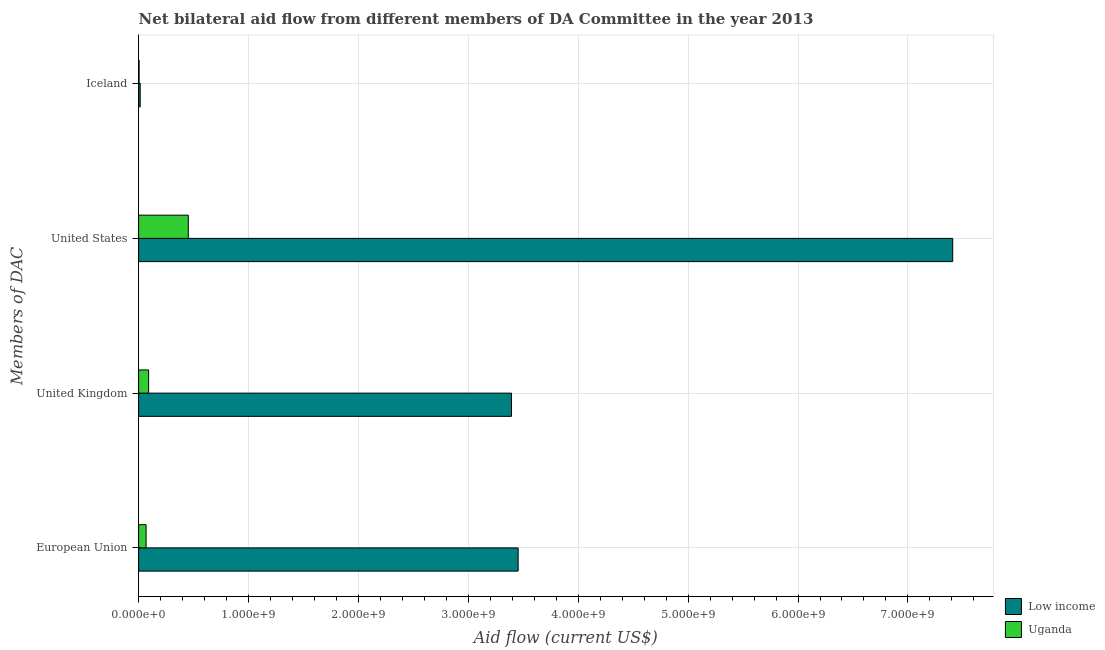How many different coloured bars are there?
Provide a succinct answer. 2. How many bars are there on the 2nd tick from the top?
Ensure brevity in your answer.  2. How many bars are there on the 1st tick from the bottom?
Make the answer very short. 2. What is the label of the 4th group of bars from the top?
Your response must be concise. European Union. What is the amount of aid given by uk in Low income?
Keep it short and to the point. 3.39e+09. Across all countries, what is the maximum amount of aid given by uk?
Ensure brevity in your answer.  3.39e+09. Across all countries, what is the minimum amount of aid given by uk?
Ensure brevity in your answer.  9.09e+07. In which country was the amount of aid given by us minimum?
Offer a terse response. Uganda. What is the total amount of aid given by us in the graph?
Offer a very short reply. 7.86e+09. What is the difference between the amount of aid given by eu in Uganda and that in Low income?
Offer a terse response. -3.39e+09. What is the difference between the amount of aid given by us in Uganda and the amount of aid given by eu in Low income?
Offer a terse response. -3.00e+09. What is the average amount of aid given by uk per country?
Offer a very short reply. 1.74e+09. What is the difference between the amount of aid given by eu and amount of aid given by iceland in Uganda?
Offer a terse response. 6.38e+07. In how many countries, is the amount of aid given by uk greater than 1800000000 US$?
Make the answer very short. 1. What is the ratio of the amount of aid given by uk in Uganda to that in Low income?
Keep it short and to the point. 0.03. Is the difference between the amount of aid given by iceland in Low income and Uganda greater than the difference between the amount of aid given by eu in Low income and Uganda?
Offer a very short reply. No. What is the difference between the highest and the second highest amount of aid given by eu?
Provide a short and direct response. 3.39e+09. What is the difference between the highest and the lowest amount of aid given by iceland?
Give a very brief answer. 1.01e+07. In how many countries, is the amount of aid given by iceland greater than the average amount of aid given by iceland taken over all countries?
Make the answer very short. 1. Is it the case that in every country, the sum of the amount of aid given by uk and amount of aid given by iceland is greater than the sum of amount of aid given by eu and amount of aid given by us?
Make the answer very short. No. What does the 1st bar from the bottom in United Kingdom represents?
Provide a succinct answer. Low income. How many bars are there?
Your answer should be very brief. 8. What is the difference between two consecutive major ticks on the X-axis?
Give a very brief answer. 1.00e+09. Does the graph contain any zero values?
Provide a short and direct response. No. How many legend labels are there?
Keep it short and to the point. 2. What is the title of the graph?
Your answer should be compact. Net bilateral aid flow from different members of DA Committee in the year 2013. What is the label or title of the Y-axis?
Offer a very short reply. Members of DAC. What is the Aid flow (current US$) in Low income in European Union?
Make the answer very short. 3.45e+09. What is the Aid flow (current US$) in Uganda in European Union?
Your response must be concise. 6.80e+07. What is the Aid flow (current US$) of Low income in United Kingdom?
Make the answer very short. 3.39e+09. What is the Aid flow (current US$) in Uganda in United Kingdom?
Your response must be concise. 9.09e+07. What is the Aid flow (current US$) in Low income in United States?
Keep it short and to the point. 7.41e+09. What is the Aid flow (current US$) of Uganda in United States?
Your response must be concise. 4.52e+08. What is the Aid flow (current US$) of Low income in Iceland?
Make the answer very short. 1.43e+07. What is the Aid flow (current US$) in Uganda in Iceland?
Your answer should be compact. 4.17e+06. Across all Members of DAC, what is the maximum Aid flow (current US$) in Low income?
Give a very brief answer. 7.41e+09. Across all Members of DAC, what is the maximum Aid flow (current US$) of Uganda?
Keep it short and to the point. 4.52e+08. Across all Members of DAC, what is the minimum Aid flow (current US$) of Low income?
Your answer should be compact. 1.43e+07. Across all Members of DAC, what is the minimum Aid flow (current US$) of Uganda?
Your response must be concise. 4.17e+06. What is the total Aid flow (current US$) in Low income in the graph?
Your answer should be compact. 1.43e+1. What is the total Aid flow (current US$) in Uganda in the graph?
Give a very brief answer. 6.15e+08. What is the difference between the Aid flow (current US$) of Low income in European Union and that in United Kingdom?
Provide a succinct answer. 6.09e+07. What is the difference between the Aid flow (current US$) in Uganda in European Union and that in United Kingdom?
Provide a short and direct response. -2.30e+07. What is the difference between the Aid flow (current US$) of Low income in European Union and that in United States?
Provide a succinct answer. -3.95e+09. What is the difference between the Aid flow (current US$) in Uganda in European Union and that in United States?
Ensure brevity in your answer.  -3.84e+08. What is the difference between the Aid flow (current US$) of Low income in European Union and that in Iceland?
Keep it short and to the point. 3.44e+09. What is the difference between the Aid flow (current US$) in Uganda in European Union and that in Iceland?
Your response must be concise. 6.38e+07. What is the difference between the Aid flow (current US$) of Low income in United Kingdom and that in United States?
Offer a very short reply. -4.02e+09. What is the difference between the Aid flow (current US$) of Uganda in United Kingdom and that in United States?
Offer a terse response. -3.61e+08. What is the difference between the Aid flow (current US$) of Low income in United Kingdom and that in Iceland?
Ensure brevity in your answer.  3.38e+09. What is the difference between the Aid flow (current US$) in Uganda in United Kingdom and that in Iceland?
Provide a succinct answer. 8.68e+07. What is the difference between the Aid flow (current US$) of Low income in United States and that in Iceland?
Your answer should be very brief. 7.39e+09. What is the difference between the Aid flow (current US$) in Uganda in United States and that in Iceland?
Your response must be concise. 4.48e+08. What is the difference between the Aid flow (current US$) of Low income in European Union and the Aid flow (current US$) of Uganda in United Kingdom?
Give a very brief answer. 3.36e+09. What is the difference between the Aid flow (current US$) in Low income in European Union and the Aid flow (current US$) in Uganda in United States?
Provide a succinct answer. 3.00e+09. What is the difference between the Aid flow (current US$) in Low income in European Union and the Aid flow (current US$) in Uganda in Iceland?
Give a very brief answer. 3.45e+09. What is the difference between the Aid flow (current US$) in Low income in United Kingdom and the Aid flow (current US$) in Uganda in United States?
Offer a terse response. 2.94e+09. What is the difference between the Aid flow (current US$) in Low income in United Kingdom and the Aid flow (current US$) in Uganda in Iceland?
Your response must be concise. 3.39e+09. What is the difference between the Aid flow (current US$) of Low income in United States and the Aid flow (current US$) of Uganda in Iceland?
Your answer should be compact. 7.40e+09. What is the average Aid flow (current US$) of Low income per Members of DAC?
Offer a very short reply. 3.57e+09. What is the average Aid flow (current US$) in Uganda per Members of DAC?
Make the answer very short. 1.54e+08. What is the difference between the Aid flow (current US$) of Low income and Aid flow (current US$) of Uganda in European Union?
Provide a short and direct response. 3.39e+09. What is the difference between the Aid flow (current US$) in Low income and Aid flow (current US$) in Uganda in United Kingdom?
Make the answer very short. 3.30e+09. What is the difference between the Aid flow (current US$) of Low income and Aid flow (current US$) of Uganda in United States?
Offer a terse response. 6.96e+09. What is the difference between the Aid flow (current US$) of Low income and Aid flow (current US$) of Uganda in Iceland?
Keep it short and to the point. 1.01e+07. What is the ratio of the Aid flow (current US$) of Low income in European Union to that in United Kingdom?
Provide a succinct answer. 1.02. What is the ratio of the Aid flow (current US$) in Uganda in European Union to that in United Kingdom?
Your answer should be very brief. 0.75. What is the ratio of the Aid flow (current US$) in Low income in European Union to that in United States?
Make the answer very short. 0.47. What is the ratio of the Aid flow (current US$) in Uganda in European Union to that in United States?
Your answer should be very brief. 0.15. What is the ratio of the Aid flow (current US$) in Low income in European Union to that in Iceland?
Provide a short and direct response. 241.66. What is the ratio of the Aid flow (current US$) in Uganda in European Union to that in Iceland?
Give a very brief answer. 16.3. What is the ratio of the Aid flow (current US$) of Low income in United Kingdom to that in United States?
Give a very brief answer. 0.46. What is the ratio of the Aid flow (current US$) in Uganda in United Kingdom to that in United States?
Make the answer very short. 0.2. What is the ratio of the Aid flow (current US$) in Low income in United Kingdom to that in Iceland?
Give a very brief answer. 237.41. What is the ratio of the Aid flow (current US$) in Uganda in United Kingdom to that in Iceland?
Ensure brevity in your answer.  21.81. What is the ratio of the Aid flow (current US$) of Low income in United States to that in Iceland?
Provide a short and direct response. 518.37. What is the ratio of the Aid flow (current US$) of Uganda in United States to that in Iceland?
Offer a terse response. 108.39. What is the difference between the highest and the second highest Aid flow (current US$) in Low income?
Give a very brief answer. 3.95e+09. What is the difference between the highest and the second highest Aid flow (current US$) in Uganda?
Your answer should be very brief. 3.61e+08. What is the difference between the highest and the lowest Aid flow (current US$) of Low income?
Offer a terse response. 7.39e+09. What is the difference between the highest and the lowest Aid flow (current US$) of Uganda?
Your answer should be very brief. 4.48e+08. 